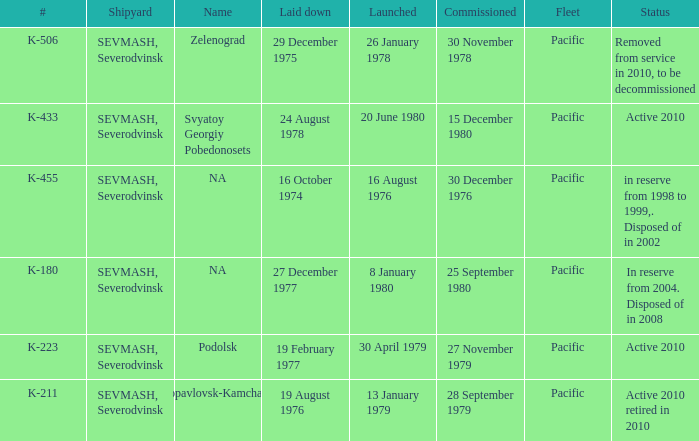Could you parse the entire table as a dict? {'header': ['#', 'Shipyard', 'Name', 'Laid down', 'Launched', 'Commissioned', 'Fleet', 'Status'], 'rows': [['K-506', 'SEVMASH, Severodvinsk', 'Zelenograd', '29 December 1975', '26 January 1978', '30 November 1978', 'Pacific', 'Removed from service in 2010, to be decommissioned'], ['K-433', 'SEVMASH, Severodvinsk', 'Svyatoy Georgiy Pobedonosets', '24 August 1978', '20 June 1980', '15 December 1980', 'Pacific', 'Active 2010'], ['K-455', 'SEVMASH, Severodvinsk', 'NA', '16 October 1974', '16 August 1976', '30 December 1976', 'Pacific', 'in reserve from 1998 to 1999,. Disposed of in 2002'], ['K-180', 'SEVMASH, Severodvinsk', 'NA', '27 December 1977', '8 January 1980', '25 September 1980', 'Pacific', 'In reserve from 2004. Disposed of in 2008'], ['K-223', 'SEVMASH, Severodvinsk', 'Podolsk', '19 February 1977', '30 April 1979', '27 November 1979', 'Pacific', 'Active 2010'], ['K-211', 'SEVMASH, Severodvinsk', 'Petropavlovsk-Kamchatskiy', '19 August 1976', '13 January 1979', '28 September 1979', 'Pacific', 'Active 2010 retired in 2010']]} What is the status of vessel number K-223? Active 2010. 